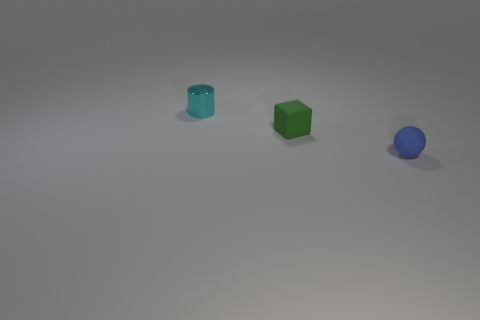Add 1 blue rubber objects. How many objects exist? 4 Subtract all spheres. How many objects are left? 2 Subtract all tiny cubes. Subtract all small rubber objects. How many objects are left? 0 Add 3 tiny cylinders. How many tiny cylinders are left? 4 Add 3 tiny gray metallic objects. How many tiny gray metallic objects exist? 3 Subtract 0 red cylinders. How many objects are left? 3 Subtract 1 balls. How many balls are left? 0 Subtract all red spheres. Subtract all green cylinders. How many spheres are left? 1 Subtract all blue balls. How many brown cylinders are left? 0 